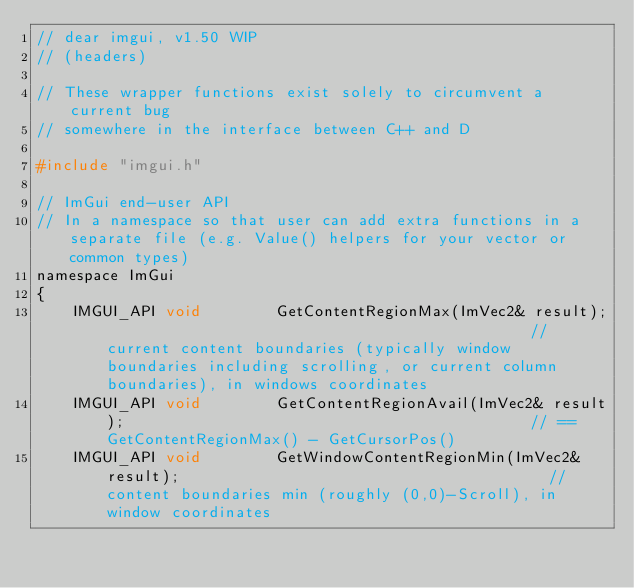<code> <loc_0><loc_0><loc_500><loc_500><_C_>// dear imgui, v1.50 WIP
// (headers)

// These wrapper functions exist solely to circumvent a current bug
// somewhere in the interface between C++ and D

#include "imgui.h"

// ImGui end-user API
// In a namespace so that user can add extra functions in a separate file (e.g. Value() helpers for your vector or common types)
namespace ImGui
{
    IMGUI_API void        GetContentRegionMax(ImVec2& result);                                              // current content boundaries (typically window boundaries including scrolling, or current column boundaries), in windows coordinates
    IMGUI_API void        GetContentRegionAvail(ImVec2& result);                                            // == GetContentRegionMax() - GetCursorPos()
    IMGUI_API void        GetWindowContentRegionMin(ImVec2& result);                                        // content boundaries min (roughly (0,0)-Scroll), in window coordinates</code> 